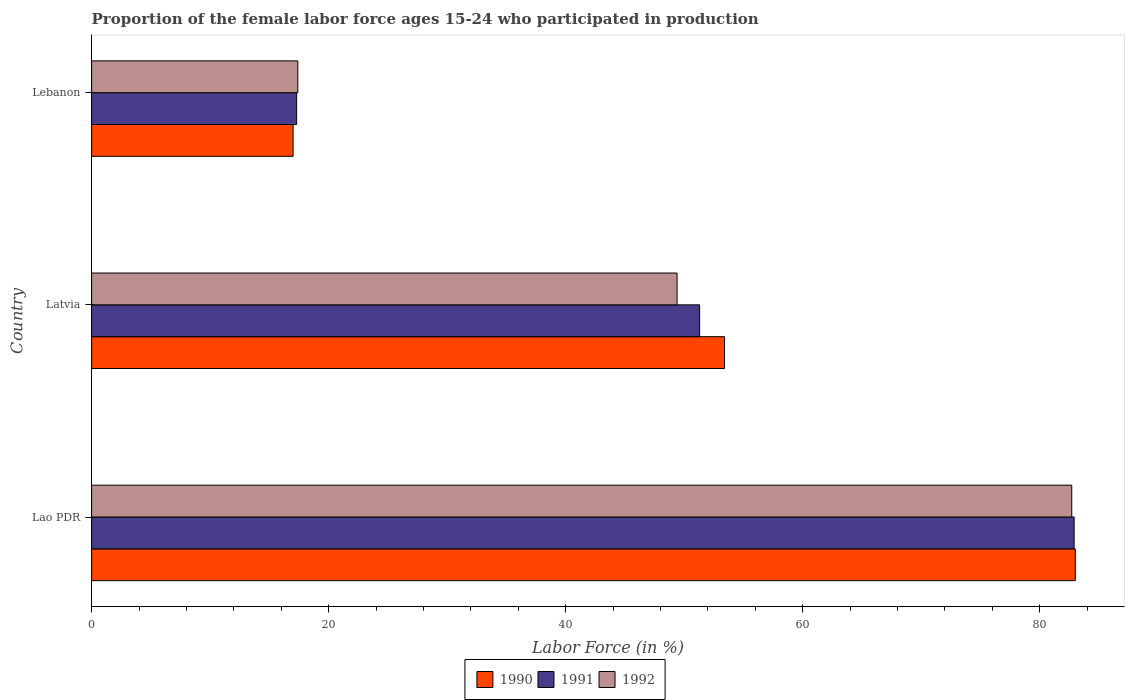How many different coloured bars are there?
Your answer should be very brief. 3. How many bars are there on the 2nd tick from the bottom?
Make the answer very short. 3. What is the label of the 3rd group of bars from the top?
Provide a succinct answer. Lao PDR. In how many cases, is the number of bars for a given country not equal to the number of legend labels?
Ensure brevity in your answer.  0. What is the proportion of the female labor force who participated in production in 1991 in Latvia?
Keep it short and to the point. 51.3. Across all countries, what is the minimum proportion of the female labor force who participated in production in 1991?
Offer a very short reply. 17.3. In which country was the proportion of the female labor force who participated in production in 1991 maximum?
Give a very brief answer. Lao PDR. In which country was the proportion of the female labor force who participated in production in 1991 minimum?
Offer a terse response. Lebanon. What is the total proportion of the female labor force who participated in production in 1992 in the graph?
Your response must be concise. 149.5. What is the difference between the proportion of the female labor force who participated in production in 1990 in Lao PDR and that in Latvia?
Ensure brevity in your answer.  29.6. What is the difference between the proportion of the female labor force who participated in production in 1990 in Lao PDR and the proportion of the female labor force who participated in production in 1991 in Lebanon?
Your answer should be very brief. 65.7. What is the average proportion of the female labor force who participated in production in 1991 per country?
Your answer should be compact. 50.5. What is the difference between the proportion of the female labor force who participated in production in 1990 and proportion of the female labor force who participated in production in 1991 in Latvia?
Your response must be concise. 2.1. What is the ratio of the proportion of the female labor force who participated in production in 1991 in Lao PDR to that in Lebanon?
Keep it short and to the point. 4.79. Is the difference between the proportion of the female labor force who participated in production in 1990 in Lao PDR and Lebanon greater than the difference between the proportion of the female labor force who participated in production in 1991 in Lao PDR and Lebanon?
Your answer should be compact. Yes. What is the difference between the highest and the second highest proportion of the female labor force who participated in production in 1990?
Your answer should be compact. 29.6. What is the difference between the highest and the lowest proportion of the female labor force who participated in production in 1992?
Ensure brevity in your answer.  65.3. Is the sum of the proportion of the female labor force who participated in production in 1992 in Lao PDR and Lebanon greater than the maximum proportion of the female labor force who participated in production in 1990 across all countries?
Your answer should be very brief. Yes. What does the 2nd bar from the bottom in Latvia represents?
Offer a terse response. 1991. Are all the bars in the graph horizontal?
Provide a short and direct response. Yes. How many countries are there in the graph?
Your answer should be compact. 3. How are the legend labels stacked?
Offer a very short reply. Horizontal. What is the title of the graph?
Offer a terse response. Proportion of the female labor force ages 15-24 who participated in production. Does "1992" appear as one of the legend labels in the graph?
Your answer should be very brief. Yes. What is the label or title of the Y-axis?
Keep it short and to the point. Country. What is the Labor Force (in %) in 1991 in Lao PDR?
Give a very brief answer. 82.9. What is the Labor Force (in %) of 1992 in Lao PDR?
Your response must be concise. 82.7. What is the Labor Force (in %) in 1990 in Latvia?
Offer a very short reply. 53.4. What is the Labor Force (in %) of 1991 in Latvia?
Your answer should be very brief. 51.3. What is the Labor Force (in %) of 1992 in Latvia?
Provide a short and direct response. 49.4. What is the Labor Force (in %) in 1991 in Lebanon?
Keep it short and to the point. 17.3. What is the Labor Force (in %) of 1992 in Lebanon?
Offer a terse response. 17.4. Across all countries, what is the maximum Labor Force (in %) in 1991?
Your answer should be compact. 82.9. Across all countries, what is the maximum Labor Force (in %) in 1992?
Provide a succinct answer. 82.7. Across all countries, what is the minimum Labor Force (in %) of 1991?
Your answer should be very brief. 17.3. Across all countries, what is the minimum Labor Force (in %) in 1992?
Make the answer very short. 17.4. What is the total Labor Force (in %) of 1990 in the graph?
Your response must be concise. 153.4. What is the total Labor Force (in %) in 1991 in the graph?
Keep it short and to the point. 151.5. What is the total Labor Force (in %) in 1992 in the graph?
Give a very brief answer. 149.5. What is the difference between the Labor Force (in %) of 1990 in Lao PDR and that in Latvia?
Your response must be concise. 29.6. What is the difference between the Labor Force (in %) in 1991 in Lao PDR and that in Latvia?
Your answer should be very brief. 31.6. What is the difference between the Labor Force (in %) in 1992 in Lao PDR and that in Latvia?
Ensure brevity in your answer.  33.3. What is the difference between the Labor Force (in %) in 1990 in Lao PDR and that in Lebanon?
Ensure brevity in your answer.  66. What is the difference between the Labor Force (in %) in 1991 in Lao PDR and that in Lebanon?
Provide a short and direct response. 65.6. What is the difference between the Labor Force (in %) of 1992 in Lao PDR and that in Lebanon?
Ensure brevity in your answer.  65.3. What is the difference between the Labor Force (in %) in 1990 in Latvia and that in Lebanon?
Give a very brief answer. 36.4. What is the difference between the Labor Force (in %) in 1991 in Latvia and that in Lebanon?
Ensure brevity in your answer.  34. What is the difference between the Labor Force (in %) in 1992 in Latvia and that in Lebanon?
Offer a terse response. 32. What is the difference between the Labor Force (in %) of 1990 in Lao PDR and the Labor Force (in %) of 1991 in Latvia?
Keep it short and to the point. 31.7. What is the difference between the Labor Force (in %) in 1990 in Lao PDR and the Labor Force (in %) in 1992 in Latvia?
Your response must be concise. 33.6. What is the difference between the Labor Force (in %) in 1991 in Lao PDR and the Labor Force (in %) in 1992 in Latvia?
Your answer should be very brief. 33.5. What is the difference between the Labor Force (in %) of 1990 in Lao PDR and the Labor Force (in %) of 1991 in Lebanon?
Provide a succinct answer. 65.7. What is the difference between the Labor Force (in %) of 1990 in Lao PDR and the Labor Force (in %) of 1992 in Lebanon?
Provide a succinct answer. 65.6. What is the difference between the Labor Force (in %) of 1991 in Lao PDR and the Labor Force (in %) of 1992 in Lebanon?
Keep it short and to the point. 65.5. What is the difference between the Labor Force (in %) of 1990 in Latvia and the Labor Force (in %) of 1991 in Lebanon?
Provide a succinct answer. 36.1. What is the difference between the Labor Force (in %) of 1991 in Latvia and the Labor Force (in %) of 1992 in Lebanon?
Keep it short and to the point. 33.9. What is the average Labor Force (in %) of 1990 per country?
Provide a succinct answer. 51.13. What is the average Labor Force (in %) in 1991 per country?
Offer a terse response. 50.5. What is the average Labor Force (in %) in 1992 per country?
Your answer should be very brief. 49.83. What is the difference between the Labor Force (in %) in 1991 and Labor Force (in %) in 1992 in Lao PDR?
Ensure brevity in your answer.  0.2. What is the difference between the Labor Force (in %) of 1990 and Labor Force (in %) of 1992 in Lebanon?
Keep it short and to the point. -0.4. What is the difference between the Labor Force (in %) of 1991 and Labor Force (in %) of 1992 in Lebanon?
Your response must be concise. -0.1. What is the ratio of the Labor Force (in %) of 1990 in Lao PDR to that in Latvia?
Offer a terse response. 1.55. What is the ratio of the Labor Force (in %) in 1991 in Lao PDR to that in Latvia?
Your answer should be very brief. 1.62. What is the ratio of the Labor Force (in %) in 1992 in Lao PDR to that in Latvia?
Give a very brief answer. 1.67. What is the ratio of the Labor Force (in %) in 1990 in Lao PDR to that in Lebanon?
Provide a short and direct response. 4.88. What is the ratio of the Labor Force (in %) of 1991 in Lao PDR to that in Lebanon?
Make the answer very short. 4.79. What is the ratio of the Labor Force (in %) in 1992 in Lao PDR to that in Lebanon?
Offer a terse response. 4.75. What is the ratio of the Labor Force (in %) of 1990 in Latvia to that in Lebanon?
Your answer should be very brief. 3.14. What is the ratio of the Labor Force (in %) of 1991 in Latvia to that in Lebanon?
Provide a succinct answer. 2.97. What is the ratio of the Labor Force (in %) of 1992 in Latvia to that in Lebanon?
Keep it short and to the point. 2.84. What is the difference between the highest and the second highest Labor Force (in %) in 1990?
Provide a short and direct response. 29.6. What is the difference between the highest and the second highest Labor Force (in %) of 1991?
Provide a short and direct response. 31.6. What is the difference between the highest and the second highest Labor Force (in %) of 1992?
Provide a short and direct response. 33.3. What is the difference between the highest and the lowest Labor Force (in %) of 1990?
Offer a terse response. 66. What is the difference between the highest and the lowest Labor Force (in %) of 1991?
Your answer should be very brief. 65.6. What is the difference between the highest and the lowest Labor Force (in %) in 1992?
Give a very brief answer. 65.3. 